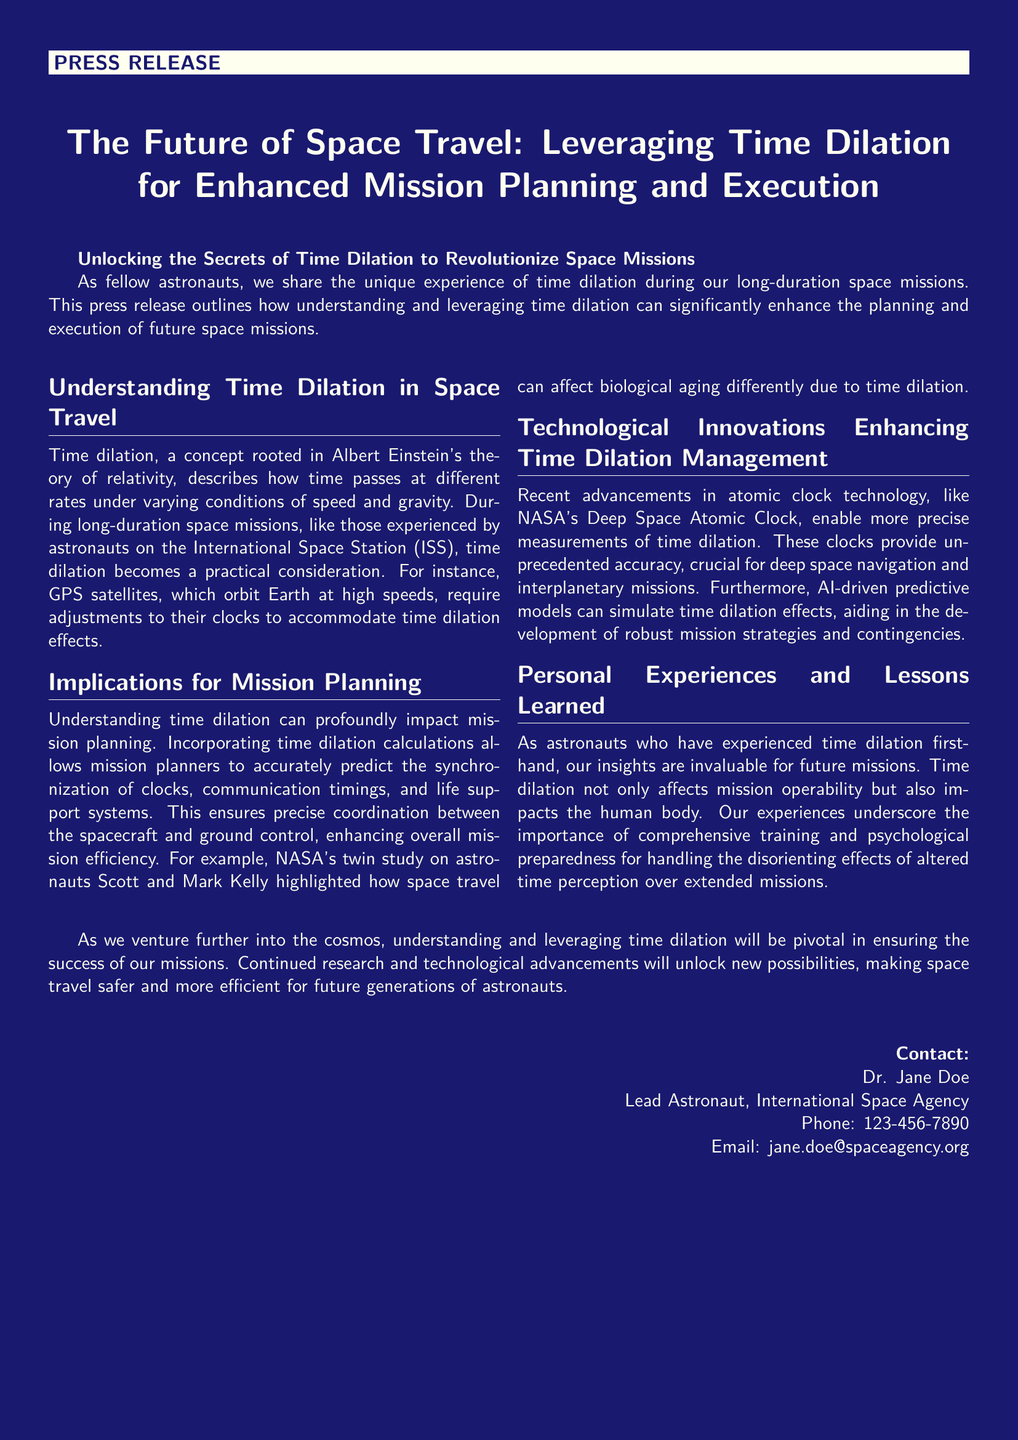What is the primary focus of the press release? The press release focuses on how understanding time dilation can enhance mission planning and execution in space travel.
Answer: Enhancing mission planning and execution Who is the lead astronaut mentioned in the document? The lead astronaut mentioned in the document is Dr. Jane Doe.
Answer: Dr. Jane Doe What technology is highlighted for its role in measuring time dilation? The document mentions the Deep Space Atomic Clock as a significant advancement in atomic clock technology.
Answer: Deep Space Atomic Clock Which astronauts were part of NASA's twin study? The astronauts in the twin study were Scott and Mark Kelly.
Answer: Scott and Mark Kelly What effect does time dilation have on biological aging? Time dilation affects biological aging differently, according to the NASA twin study.
Answer: Differently What is essential for handling the altered time perception during missions? The document emphasizes the importance of comprehensive training and psychological preparedness.
Answer: Training and psychological preparedness What broader impact is mentioned regarding time dilation for future missions? Understanding time dilation is pivotal for ensuring the success of future missions.
Answer: Ensuring mission success What institution is associated with Dr. Jane Doe in the document? Dr. Jane Doe is associated with the International Space Agency.
Answer: International Space Agency 